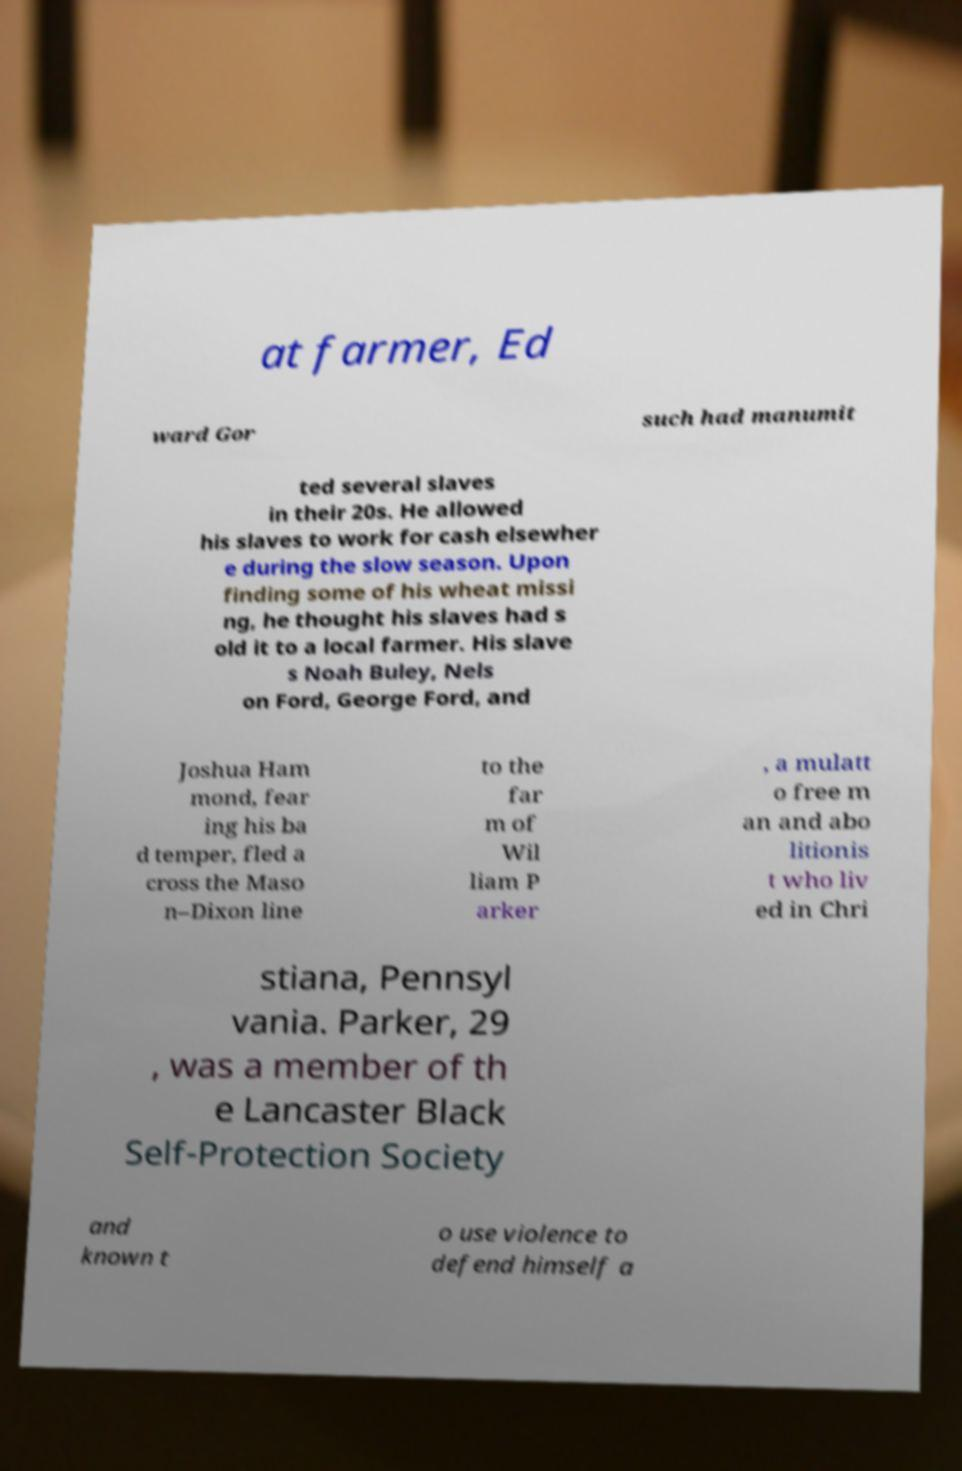Can you accurately transcribe the text from the provided image for me? at farmer, Ed ward Gor such had manumit ted several slaves in their 20s. He allowed his slaves to work for cash elsewher e during the slow season. Upon finding some of his wheat missi ng, he thought his slaves had s old it to a local farmer. His slave s Noah Buley, Nels on Ford, George Ford, and Joshua Ham mond, fear ing his ba d temper, fled a cross the Maso n–Dixon line to the far m of Wil liam P arker , a mulatt o free m an and abo litionis t who liv ed in Chri stiana, Pennsyl vania. Parker, 29 , was a member of th e Lancaster Black Self-Protection Society and known t o use violence to defend himself a 